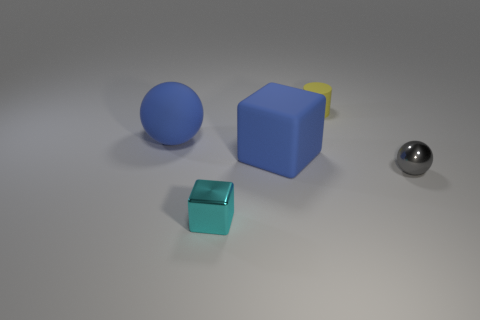What color is the tiny object that is behind the ball behind the gray metal object?
Offer a terse response. Yellow. There is a blue matte thing on the left side of the cyan metal cube; is its shape the same as the small gray metallic object in front of the small yellow object?
Offer a terse response. Yes. There is a cyan object that is the same size as the cylinder; what shape is it?
Make the answer very short. Cube. There is a tiny object that is the same material as the small cube; what color is it?
Make the answer very short. Gray. Is the shape of the small gray object the same as the blue thing on the left side of the small cyan shiny object?
Provide a succinct answer. Yes. What material is the big ball that is the same color as the big cube?
Ensure brevity in your answer.  Rubber. There is a cyan thing that is the same size as the yellow thing; what is it made of?
Give a very brief answer. Metal. Are there any big balls that have the same color as the big block?
Provide a succinct answer. Yes. There is a matte object that is both to the right of the small cyan metallic thing and left of the cylinder; what shape is it?
Your answer should be very brief. Cube. What number of tiny cyan things have the same material as the big blue sphere?
Provide a succinct answer. 0. 